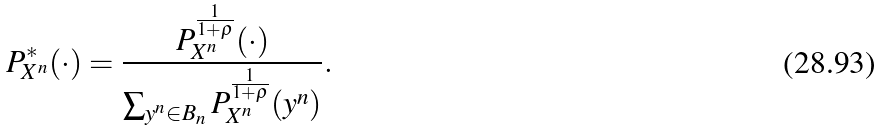Convert formula to latex. <formula><loc_0><loc_0><loc_500><loc_500>P _ { X ^ { n } } ^ { * } ( \cdot ) = \frac { P _ { X ^ { n } } ^ { \frac { 1 } { 1 + \rho } } ( \cdot ) } { \sum _ { y ^ { n } \in B _ { n } } P _ { X ^ { n } } ^ { \frac { 1 } { 1 + \rho } } ( y ^ { n } ) } .</formula> 